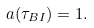Convert formula to latex. <formula><loc_0><loc_0><loc_500><loc_500>a ( \tau _ { B I } ) = 1 .</formula> 